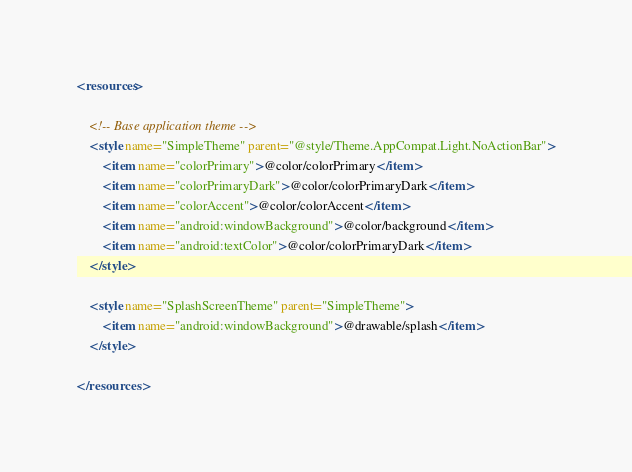Convert code to text. <code><loc_0><loc_0><loc_500><loc_500><_XML_><resources>

    <!-- Base application theme -->
    <style name="SimpleTheme" parent="@style/Theme.AppCompat.Light.NoActionBar">
        <item name="colorPrimary">@color/colorPrimary</item>
        <item name="colorPrimaryDark">@color/colorPrimaryDark</item>
        <item name="colorAccent">@color/colorAccent</item>
        <item name="android:windowBackground">@color/background</item>
        <item name="android:textColor">@color/colorPrimaryDark</item>
    </style>

    <style name="SplashScreenTheme" parent="SimpleTheme">
        <item name="android:windowBackground">@drawable/splash</item>
    </style>

</resources>
</code> 